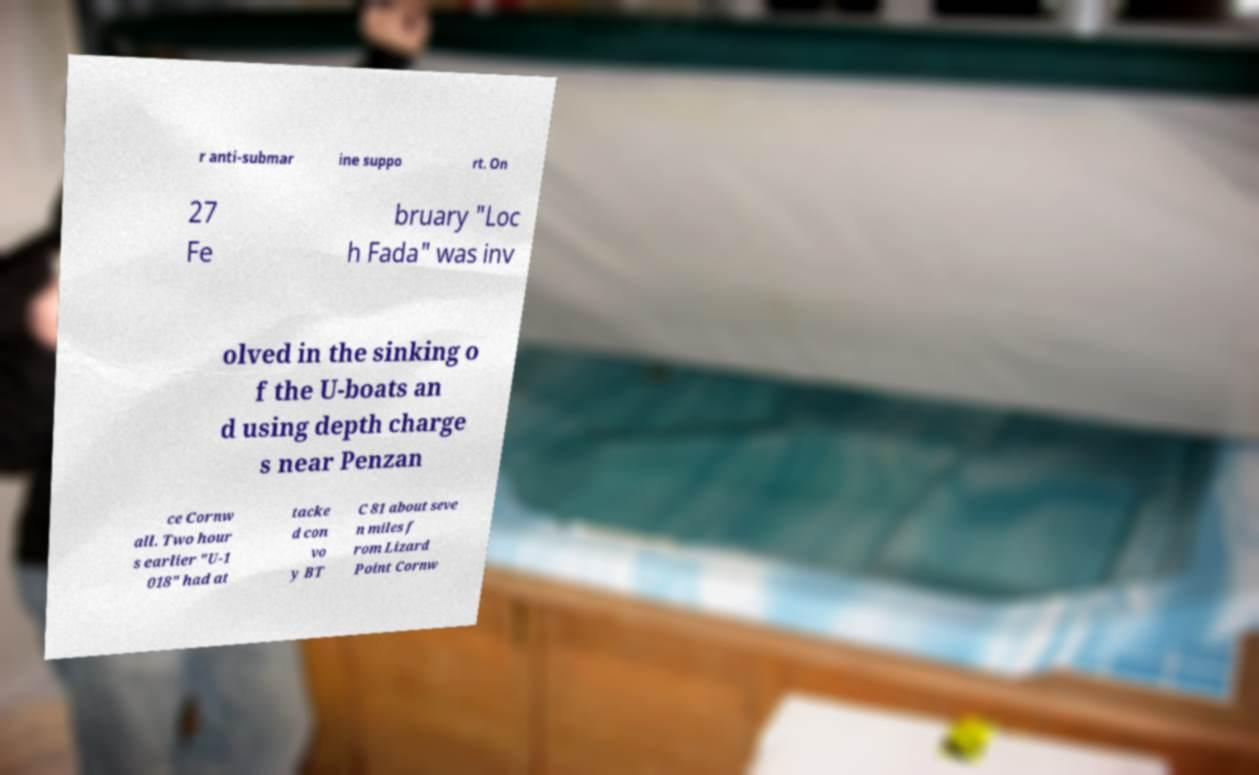There's text embedded in this image that I need extracted. Can you transcribe it verbatim? r anti-submar ine suppo rt. On 27 Fe bruary "Loc h Fada" was inv olved in the sinking o f the U-boats an d using depth charge s near Penzan ce Cornw all. Two hour s earlier "U-1 018" had at tacke d con vo y BT C 81 about seve n miles f rom Lizard Point Cornw 